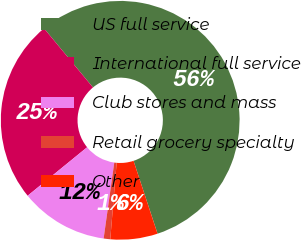Convert chart. <chart><loc_0><loc_0><loc_500><loc_500><pie_chart><fcel>US full service<fcel>International full service<fcel>Club stores and mass<fcel>Retail grocery specialty<fcel>Other<nl><fcel>55.95%<fcel>24.87%<fcel>11.9%<fcel>0.89%<fcel>6.39%<nl></chart> 